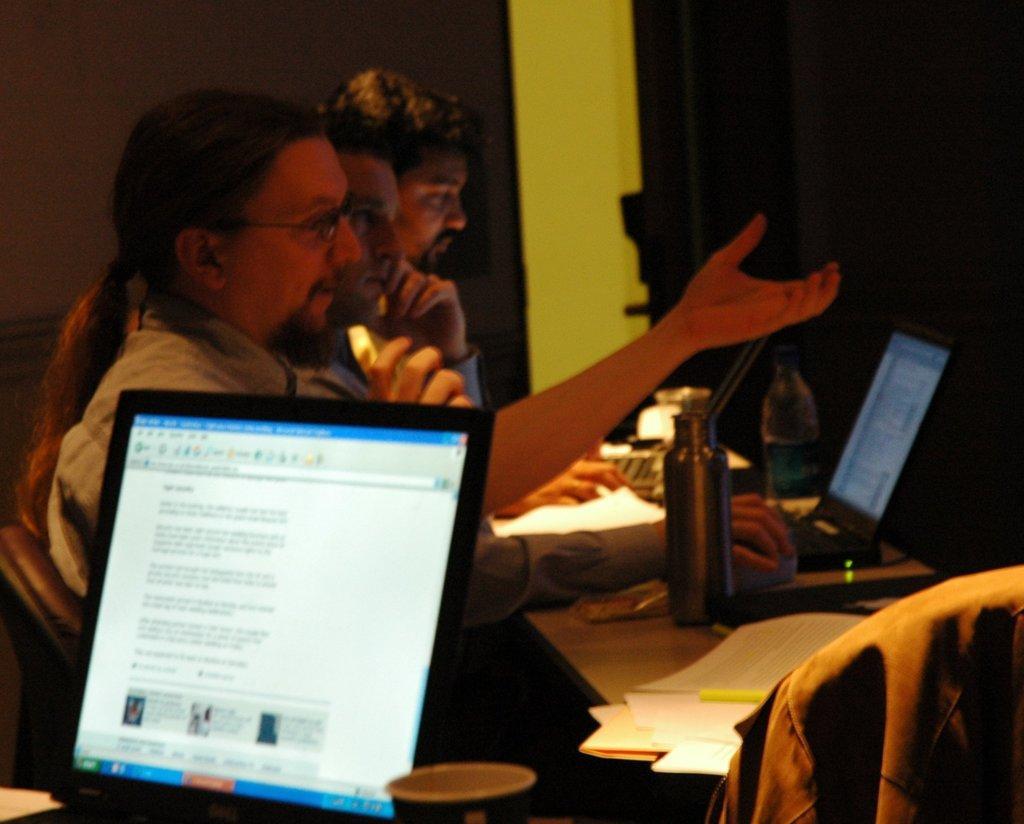Describe this image in one or two sentences. This image consist of three men. They are sitting in the chairs in front of table. On the table there are laptops, bottles, and papers. In the background, there is a wall and door. 